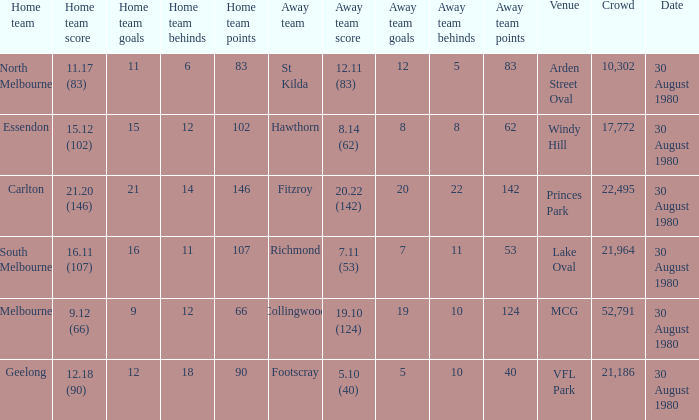What is the home team score at lake oval? 16.11 (107). 